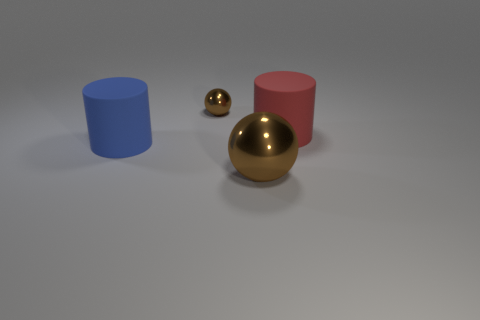Add 3 tiny purple rubber spheres. How many objects exist? 7 Subtract 0 cyan spheres. How many objects are left? 4 Subtract all big red things. Subtract all tiny things. How many objects are left? 2 Add 2 big metal things. How many big metal things are left? 3 Add 3 large metal balls. How many large metal balls exist? 4 